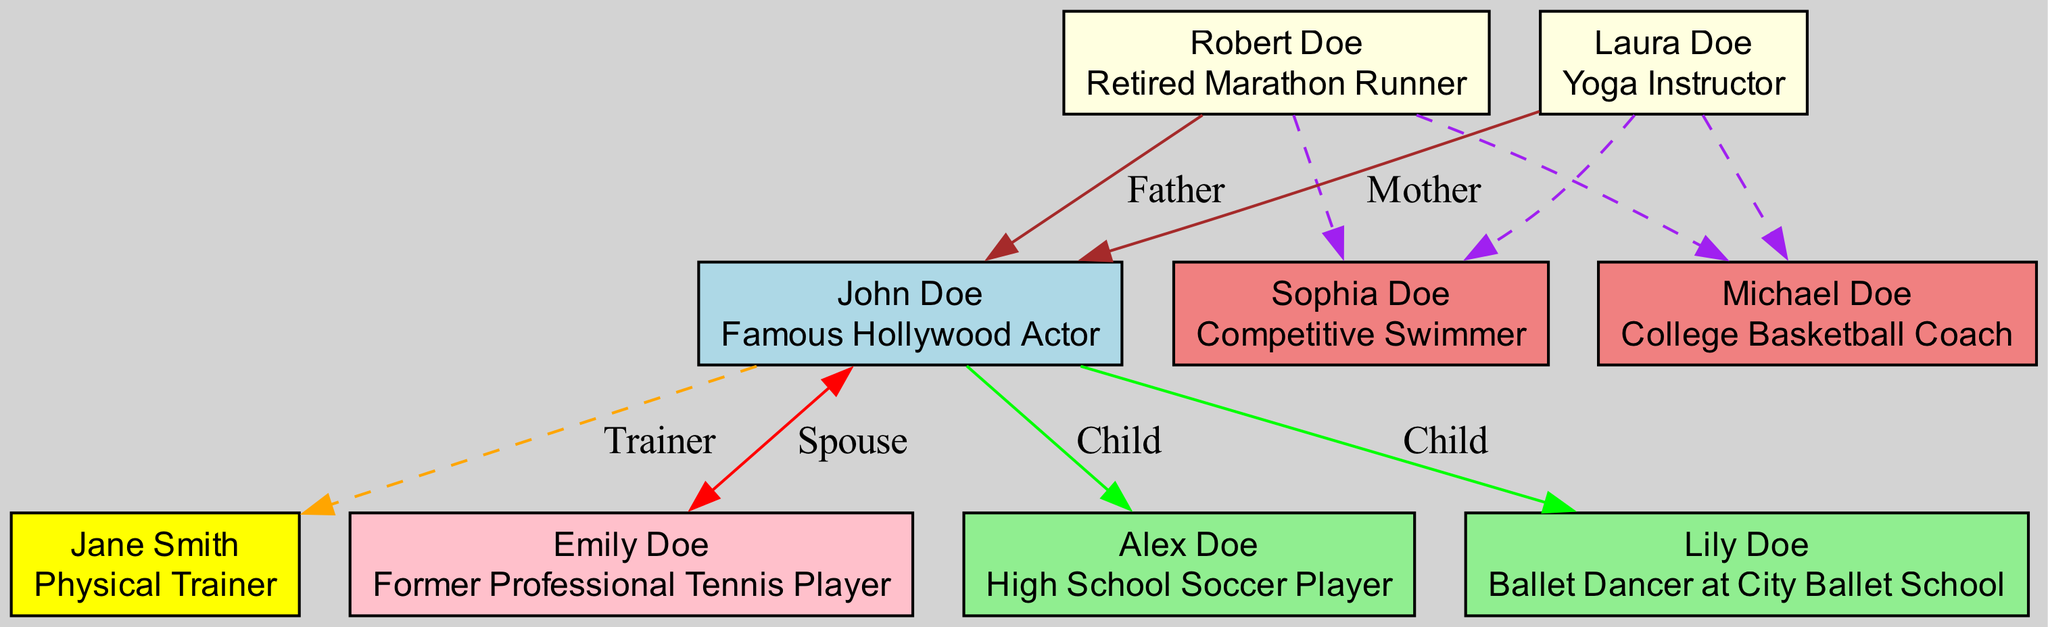What is the role of John Doe? John Doe is identified as a "Famous Hollywood Actor" in the diagram. This information is found in the main node associated with John Doe.
Answer: Famous Hollywood Actor Who is credited as John's trainer? The trainer credited by John Doe is "Jane Smith," whose role is specified as "Physical Trainer." This node is connected to John as his trainer.
Answer: Jane Smith How many children does John Doe have? The diagram shows two children listed under John's family section, which can be counted directly in the diagram.
Answer: 2 What is the relationship between John Doe and Emily Doe? The diagram states that Emily Doe is the "Spouse" of John Doe, indicating their marital relationship as indicated by the double-headed edge connecting them.
Answer: Spouse Which family member has a career related to athletics? John's father, "Robert Doe," is noted as a "Retired Marathon Runner," directly linking him to athletics. This information can be found in the parent section of the diagram.
Answer: Robert Doe What role does Sophia Doe play in the family? Sophia Doe is identified as a "Competitive Swimmer" in the diagram, which reveals her family role and profession clearly.
Answer: Competitive Swimmer List the roles of John Doe's children. The roles of the children are "High School Soccer Player" for Alex Doe and "Ballet Dancer at City Ballet School" for Lily Doe. Both roles are displayed next to their respective names in the children section.
Answer: High School Soccer Player, Ballet Dancer at City Ballet School How many siblings does John Doe have? The diagram indicates that John Doe has two siblings, "Michael Doe" and "Sophia Doe," which can be counted in the siblings section.
Answer: 2 Is there a family member involved in yoga? Yes, John's mother, "Laura Doe," is identified as a "Yoga Instructor," directly showing her involvement in yoga within the diagram.
Answer: Laura Doe 